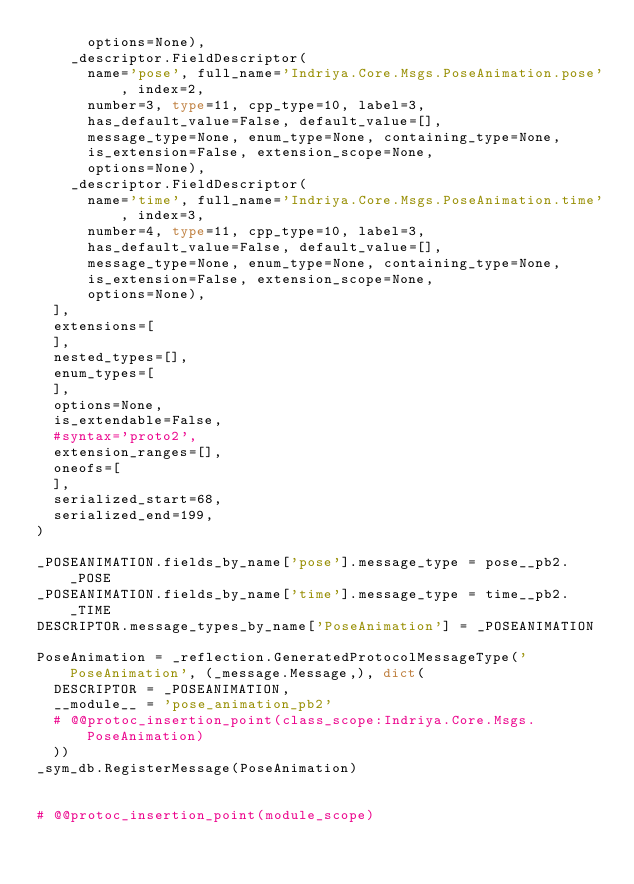<code> <loc_0><loc_0><loc_500><loc_500><_Python_>      options=None),
    _descriptor.FieldDescriptor(
      name='pose', full_name='Indriya.Core.Msgs.PoseAnimation.pose', index=2,
      number=3, type=11, cpp_type=10, label=3,
      has_default_value=False, default_value=[],
      message_type=None, enum_type=None, containing_type=None,
      is_extension=False, extension_scope=None,
      options=None),
    _descriptor.FieldDescriptor(
      name='time', full_name='Indriya.Core.Msgs.PoseAnimation.time', index=3,
      number=4, type=11, cpp_type=10, label=3,
      has_default_value=False, default_value=[],
      message_type=None, enum_type=None, containing_type=None,
      is_extension=False, extension_scope=None,
      options=None),
  ],
  extensions=[
  ],
  nested_types=[],
  enum_types=[
  ],
  options=None,
  is_extendable=False,
  #syntax='proto2',
  extension_ranges=[],
  oneofs=[
  ],
  serialized_start=68,
  serialized_end=199,
)

_POSEANIMATION.fields_by_name['pose'].message_type = pose__pb2._POSE
_POSEANIMATION.fields_by_name['time'].message_type = time__pb2._TIME
DESCRIPTOR.message_types_by_name['PoseAnimation'] = _POSEANIMATION

PoseAnimation = _reflection.GeneratedProtocolMessageType('PoseAnimation', (_message.Message,), dict(
  DESCRIPTOR = _POSEANIMATION,
  __module__ = 'pose_animation_pb2'
  # @@protoc_insertion_point(class_scope:Indriya.Core.Msgs.PoseAnimation)
  ))
_sym_db.RegisterMessage(PoseAnimation)


# @@protoc_insertion_point(module_scope)
</code> 